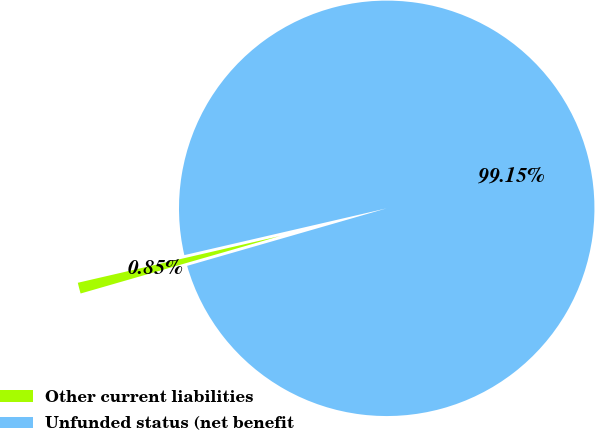Convert chart. <chart><loc_0><loc_0><loc_500><loc_500><pie_chart><fcel>Other current liabilities<fcel>Unfunded status (net benefit<nl><fcel>0.85%<fcel>99.15%<nl></chart> 